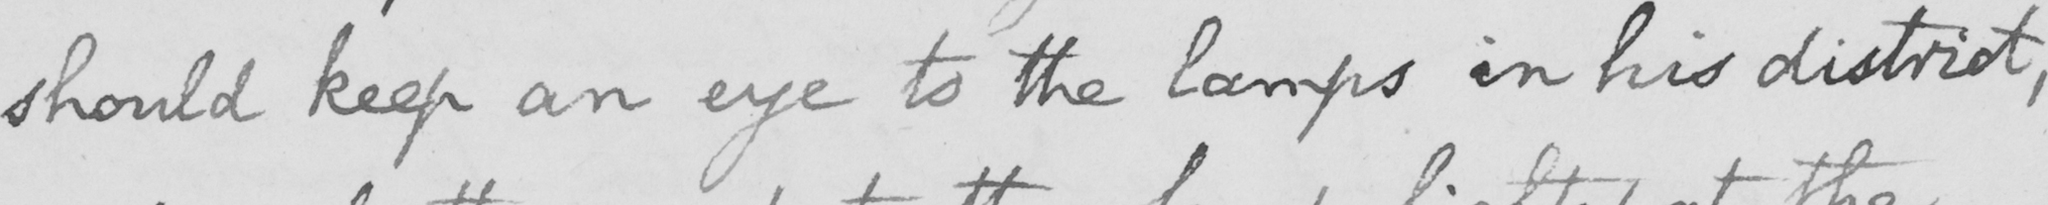What is written in this line of handwriting? should keep an eye to the lamps in his district , 